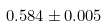Convert formula to latex. <formula><loc_0><loc_0><loc_500><loc_500>0 . 5 8 4 \pm 0 . 0 0 5</formula> 